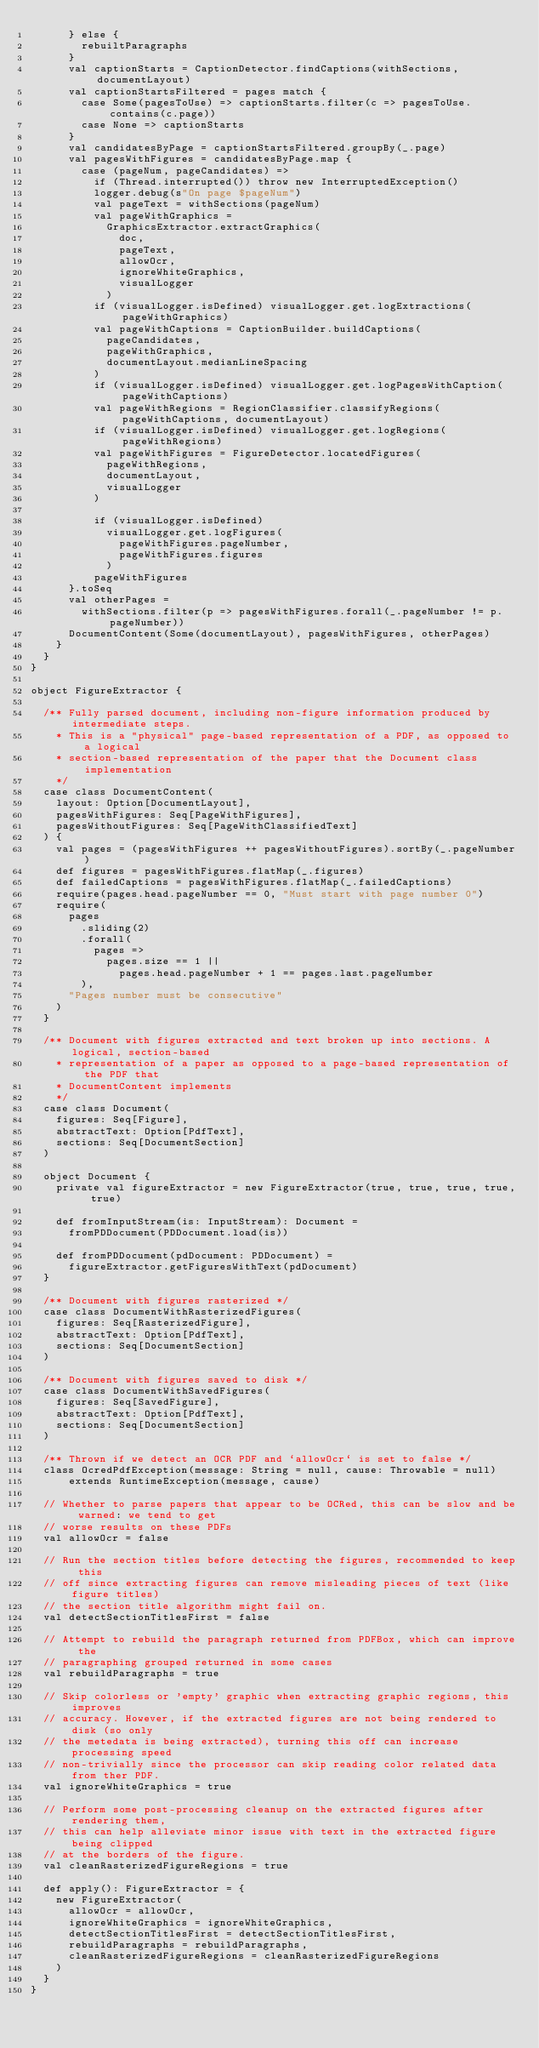<code> <loc_0><loc_0><loc_500><loc_500><_Scala_>      } else {
        rebuiltParagraphs
      }
      val captionStarts = CaptionDetector.findCaptions(withSections, documentLayout)
      val captionStartsFiltered = pages match {
        case Some(pagesToUse) => captionStarts.filter(c => pagesToUse.contains(c.page))
        case None => captionStarts
      }
      val candidatesByPage = captionStartsFiltered.groupBy(_.page)
      val pagesWithFigures = candidatesByPage.map {
        case (pageNum, pageCandidates) =>
          if (Thread.interrupted()) throw new InterruptedException()
          logger.debug(s"On page $pageNum")
          val pageText = withSections(pageNum)
          val pageWithGraphics =
            GraphicsExtractor.extractGraphics(
              doc,
              pageText,
              allowOcr,
              ignoreWhiteGraphics,
              visualLogger
            )
          if (visualLogger.isDefined) visualLogger.get.logExtractions(pageWithGraphics)
          val pageWithCaptions = CaptionBuilder.buildCaptions(
            pageCandidates,
            pageWithGraphics,
            documentLayout.medianLineSpacing
          )
          if (visualLogger.isDefined) visualLogger.get.logPagesWithCaption(pageWithCaptions)
          val pageWithRegions = RegionClassifier.classifyRegions(pageWithCaptions, documentLayout)
          if (visualLogger.isDefined) visualLogger.get.logRegions(pageWithRegions)
          val pageWithFigures = FigureDetector.locatedFigures(
            pageWithRegions,
            documentLayout,
            visualLogger
          )

          if (visualLogger.isDefined)
            visualLogger.get.logFigures(
              pageWithFigures.pageNumber,
              pageWithFigures.figures
            )
          pageWithFigures
      }.toSeq
      val otherPages =
        withSections.filter(p => pagesWithFigures.forall(_.pageNumber != p.pageNumber))
      DocumentContent(Some(documentLayout), pagesWithFigures, otherPages)
    }
  }
}

object FigureExtractor {

  /** Fully parsed document, including non-figure information produced by intermediate steps.
    * This is a "physical" page-based representation of a PDF, as opposed to a logical
    * section-based representation of the paper that the Document class implementation
    */
  case class DocumentContent(
    layout: Option[DocumentLayout],
    pagesWithFigures: Seq[PageWithFigures],
    pagesWithoutFigures: Seq[PageWithClassifiedText]
  ) {
    val pages = (pagesWithFigures ++ pagesWithoutFigures).sortBy(_.pageNumber)
    def figures = pagesWithFigures.flatMap(_.figures)
    def failedCaptions = pagesWithFigures.flatMap(_.failedCaptions)
    require(pages.head.pageNumber == 0, "Must start with page number 0")
    require(
      pages
        .sliding(2)
        .forall(
          pages =>
            pages.size == 1 ||
              pages.head.pageNumber + 1 == pages.last.pageNumber
        ),
      "Pages number must be consecutive"
    )
  }

  /** Document with figures extracted and text broken up into sections. A logical, section-based
    * representation of a paper as opposed to a page-based representation of the PDF that
    * DocumentContent implements
    */
  case class Document(
    figures: Seq[Figure],
    abstractText: Option[PdfText],
    sections: Seq[DocumentSection]
  )

  object Document {
    private val figureExtractor = new FigureExtractor(true, true, true, true, true)

    def fromInputStream(is: InputStream): Document =
      fromPDDocument(PDDocument.load(is))

    def fromPDDocument(pdDocument: PDDocument) =
      figureExtractor.getFiguresWithText(pdDocument)
  }

  /** Document with figures rasterized */
  case class DocumentWithRasterizedFigures(
    figures: Seq[RasterizedFigure],
    abstractText: Option[PdfText],
    sections: Seq[DocumentSection]
  )

  /** Document with figures saved to disk */
  case class DocumentWithSavedFigures(
    figures: Seq[SavedFigure],
    abstractText: Option[PdfText],
    sections: Seq[DocumentSection]
  )

  /** Thrown if we detect an OCR PDF and `allowOcr` is set to false */
  class OcredPdfException(message: String = null, cause: Throwable = null)
      extends RuntimeException(message, cause)

  // Whether to parse papers that appear to be OCRed, this can be slow and be warned: we tend to get
  // worse results on these PDFs
  val allowOcr = false

  // Run the section titles before detecting the figures, recommended to keep this
  // off since extracting figures can remove misleading pieces of text (like figure titles)
  // the section title algorithm might fail on.
  val detectSectionTitlesFirst = false

  // Attempt to rebuild the paragraph returned from PDFBox, which can improve the
  // paragraphing grouped returned in some cases
  val rebuildParagraphs = true

  // Skip colorless or 'empty' graphic when extracting graphic regions, this improves
  // accuracy. However, if the extracted figures are not being rendered to disk (so only
  // the metedata is being extracted), turning this off can increase processing speed
  // non-trivially since the processor can skip reading color related data from ther PDF.
  val ignoreWhiteGraphics = true

  // Perform some post-processing cleanup on the extracted figures after rendering them,
  // this can help alleviate minor issue with text in the extracted figure being clipped
  // at the borders of the figure.
  val cleanRasterizedFigureRegions = true

  def apply(): FigureExtractor = {
    new FigureExtractor(
      allowOcr = allowOcr,
      ignoreWhiteGraphics = ignoreWhiteGraphics,
      detectSectionTitlesFirst = detectSectionTitlesFirst,
      rebuildParagraphs = rebuildParagraphs,
      cleanRasterizedFigureRegions = cleanRasterizedFigureRegions
    )
  }
}
</code> 